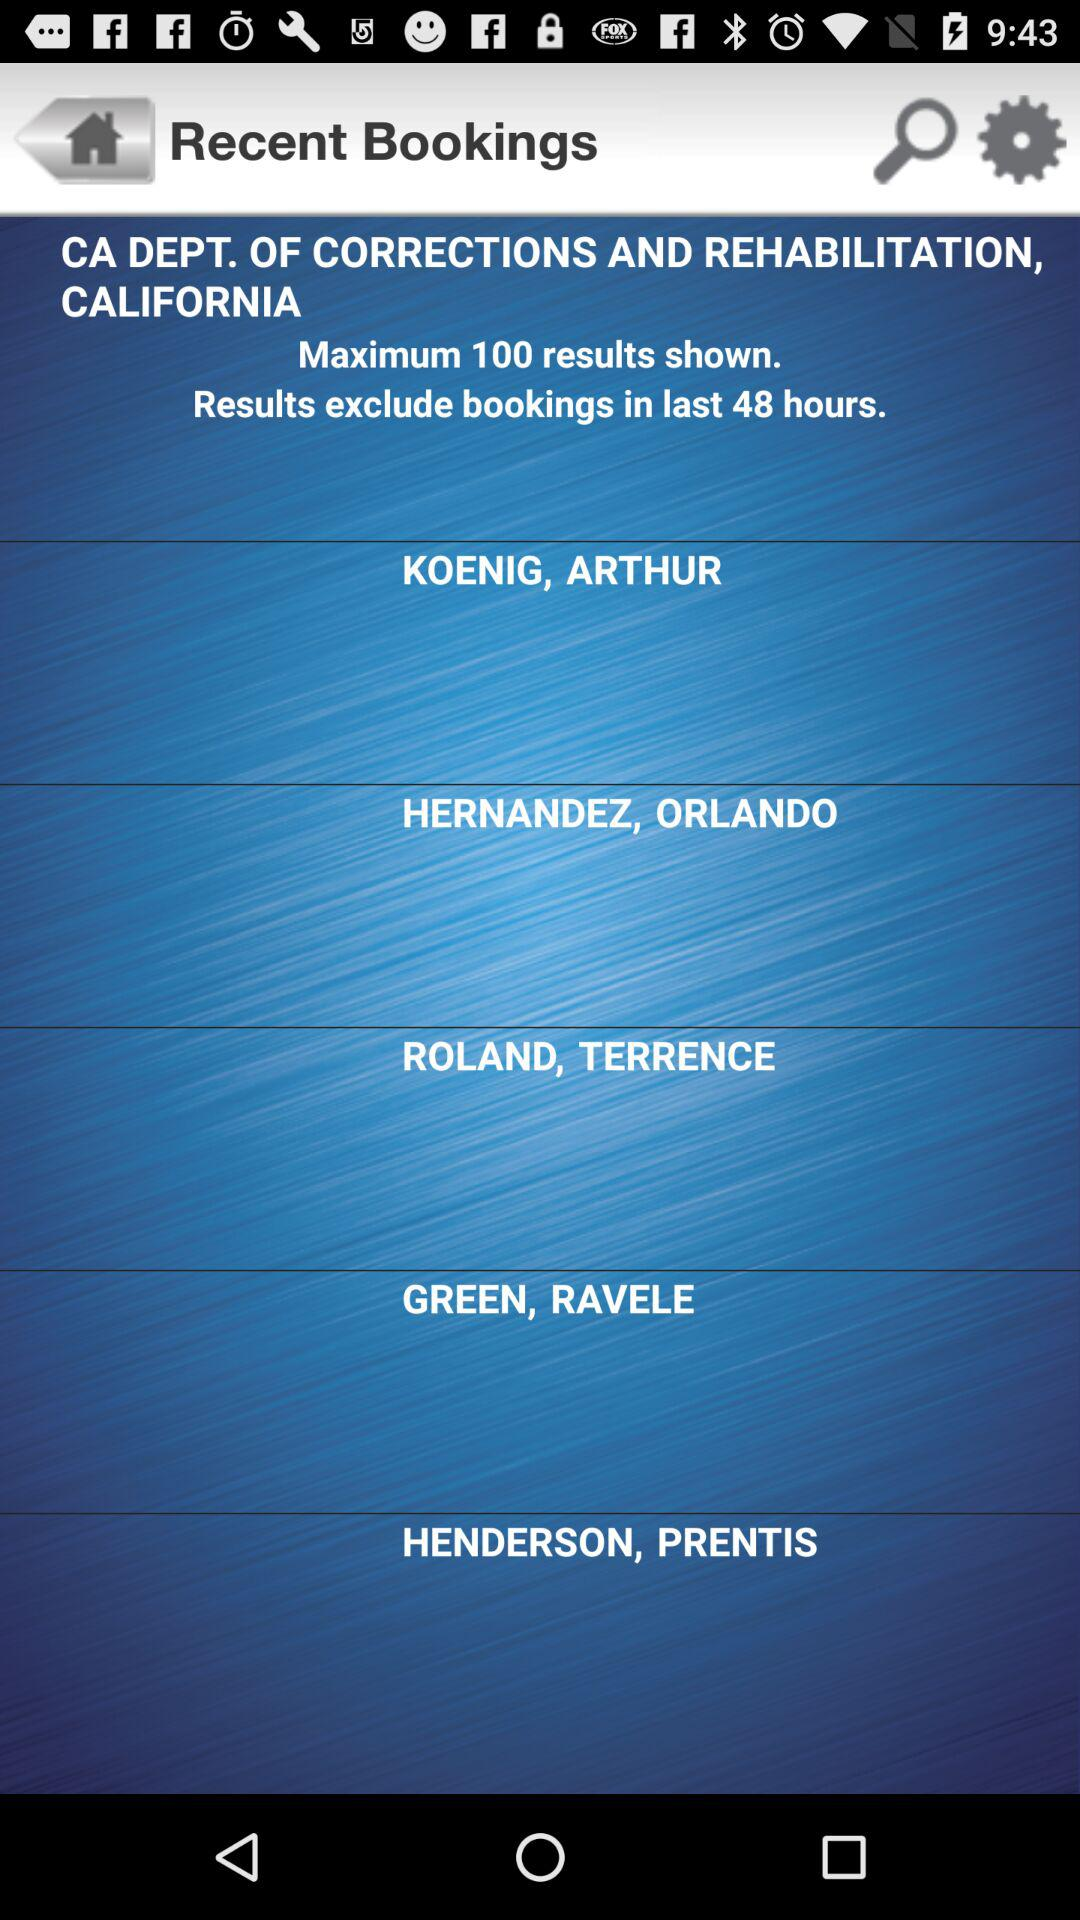What is the location? The location is the CA Department of Corrections and Rehabilitation, California. 